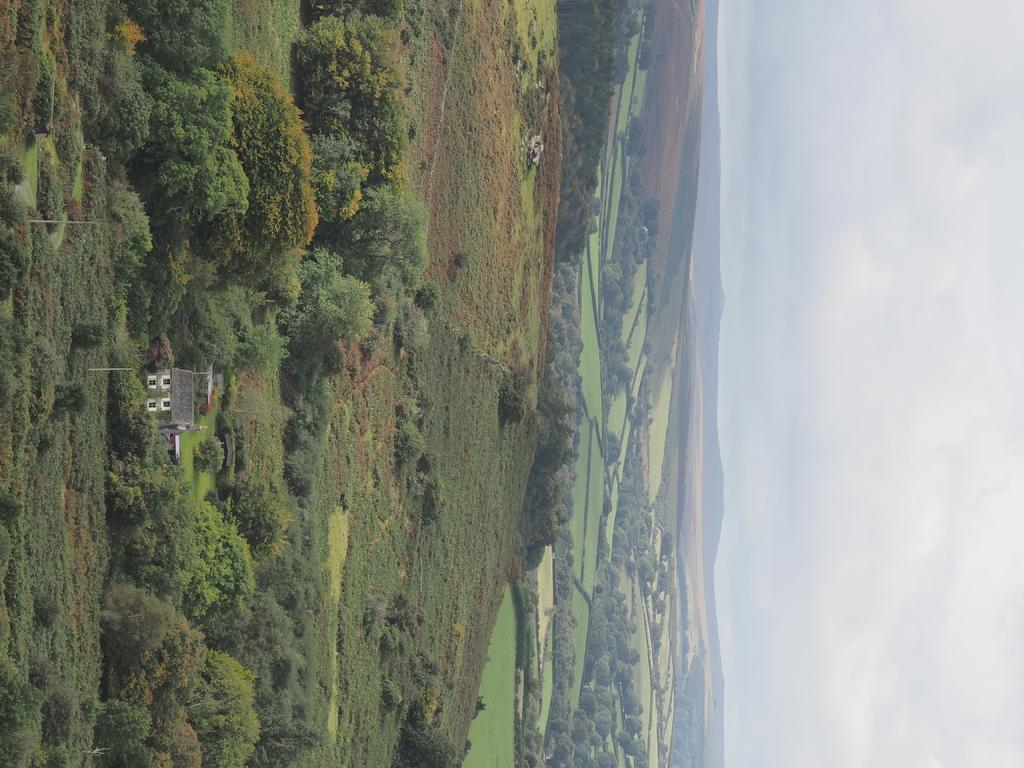What type of vegetation is present in the image? There is grass, plants, and trees in the image. Where is the house located in the image? The house is on the left side of the image. What is visible on the right side of the image? The sky is visible on the right side of the image. Can you see a fan in the image? There is no fan present in the image. How many fingers are visible in the image? There are no fingers visible in the image. 